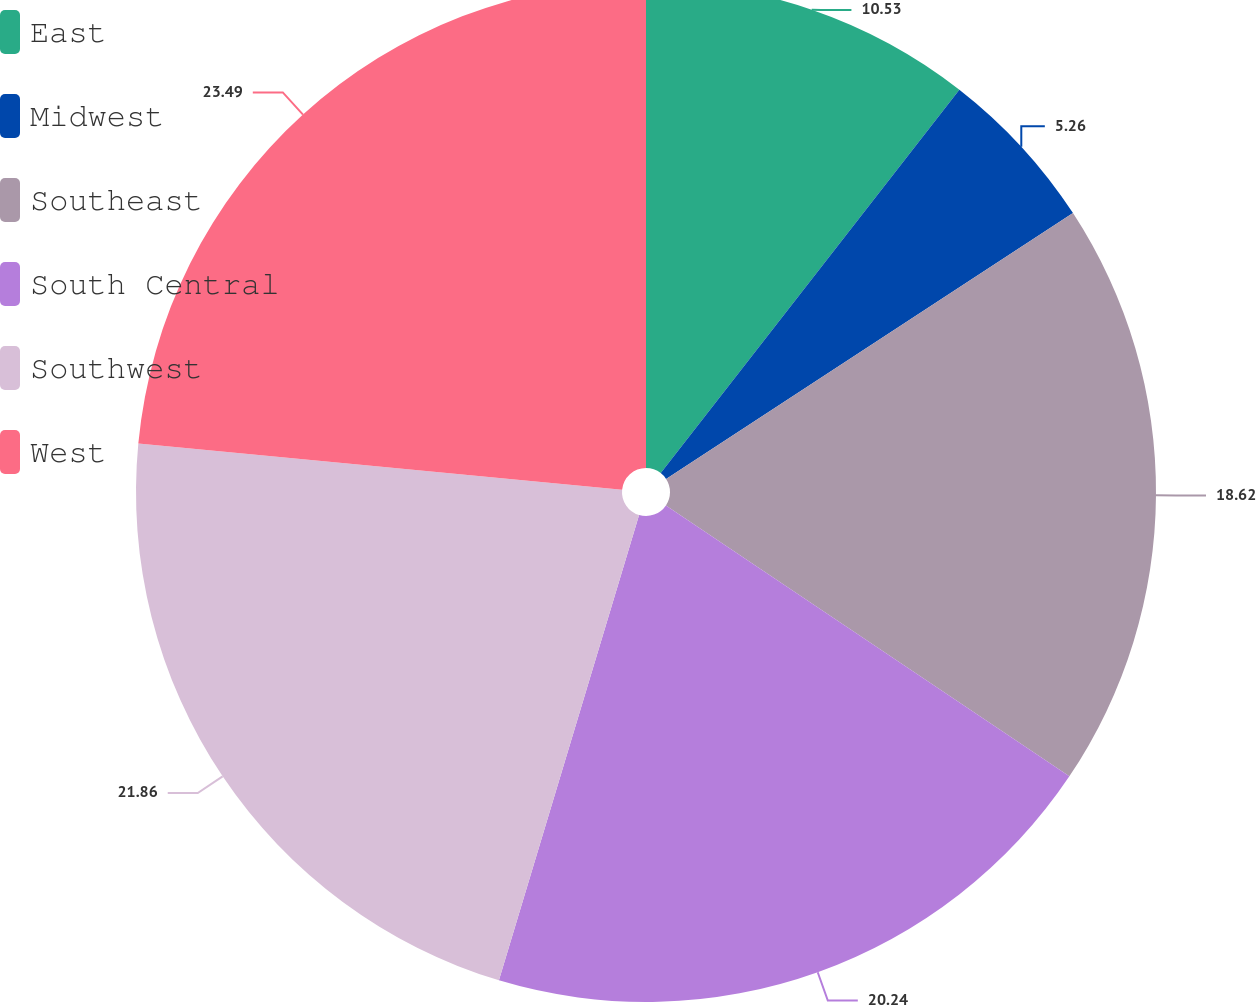<chart> <loc_0><loc_0><loc_500><loc_500><pie_chart><fcel>East<fcel>Midwest<fcel>Southeast<fcel>South Central<fcel>Southwest<fcel>West<nl><fcel>10.53%<fcel>5.26%<fcel>18.62%<fcel>20.24%<fcel>21.86%<fcel>23.48%<nl></chart> 